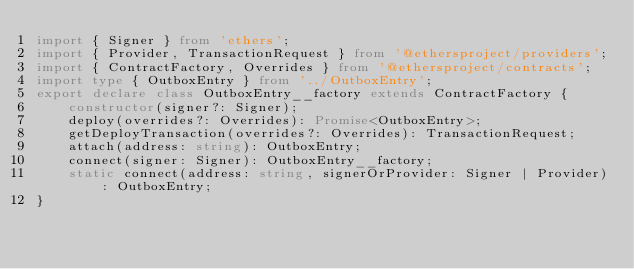<code> <loc_0><loc_0><loc_500><loc_500><_TypeScript_>import { Signer } from 'ethers';
import { Provider, TransactionRequest } from '@ethersproject/providers';
import { ContractFactory, Overrides } from '@ethersproject/contracts';
import type { OutboxEntry } from '../OutboxEntry';
export declare class OutboxEntry__factory extends ContractFactory {
    constructor(signer?: Signer);
    deploy(overrides?: Overrides): Promise<OutboxEntry>;
    getDeployTransaction(overrides?: Overrides): TransactionRequest;
    attach(address: string): OutboxEntry;
    connect(signer: Signer): OutboxEntry__factory;
    static connect(address: string, signerOrProvider: Signer | Provider): OutboxEntry;
}
</code> 